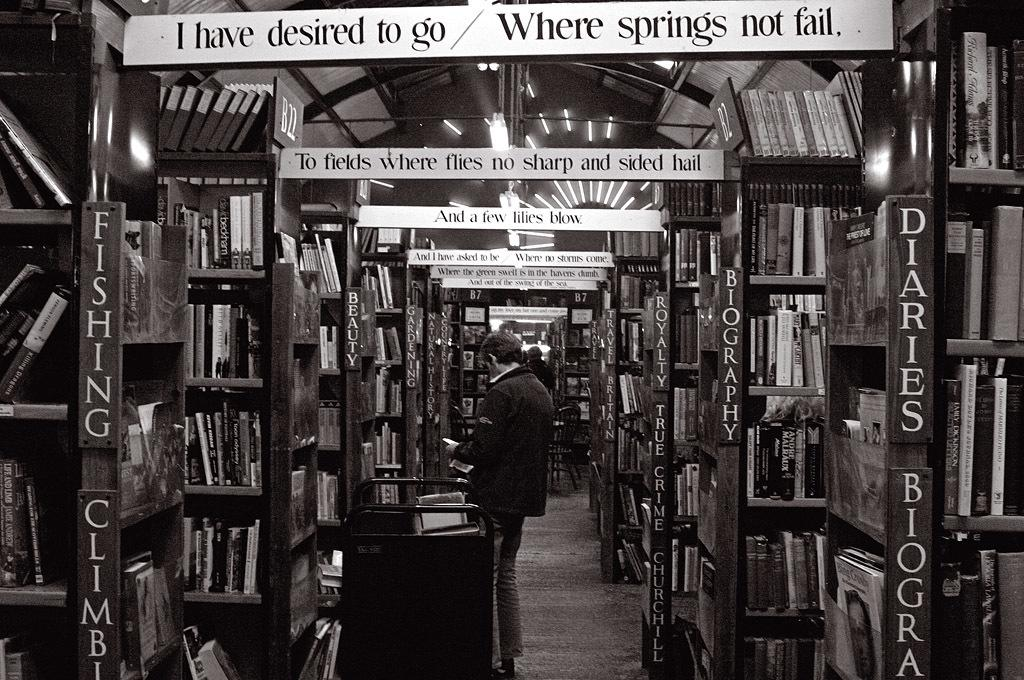<image>
Give a short and clear explanation of the subsequent image. A sign for Diaries and Biographies can be seen in a library 